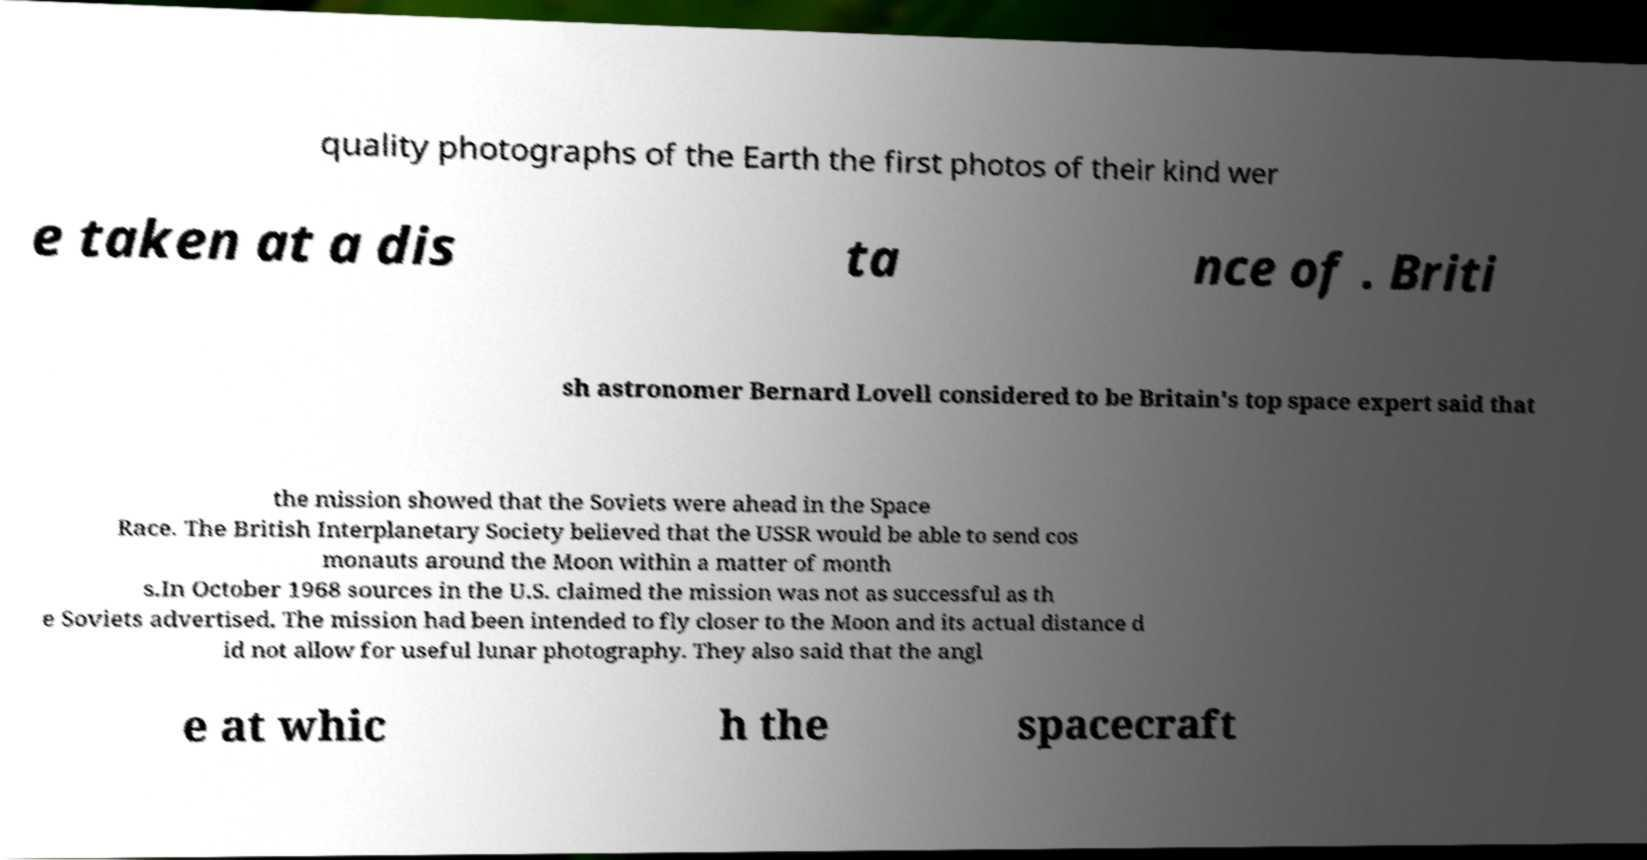Can you read and provide the text displayed in the image?This photo seems to have some interesting text. Can you extract and type it out for me? quality photographs of the Earth the first photos of their kind wer e taken at a dis ta nce of . Briti sh astronomer Bernard Lovell considered to be Britain's top space expert said that the mission showed that the Soviets were ahead in the Space Race. The British Interplanetary Society believed that the USSR would be able to send cos monauts around the Moon within a matter of month s.In October 1968 sources in the U.S. claimed the mission was not as successful as th e Soviets advertised. The mission had been intended to fly closer to the Moon and its actual distance d id not allow for useful lunar photography. They also said that the angl e at whic h the spacecraft 